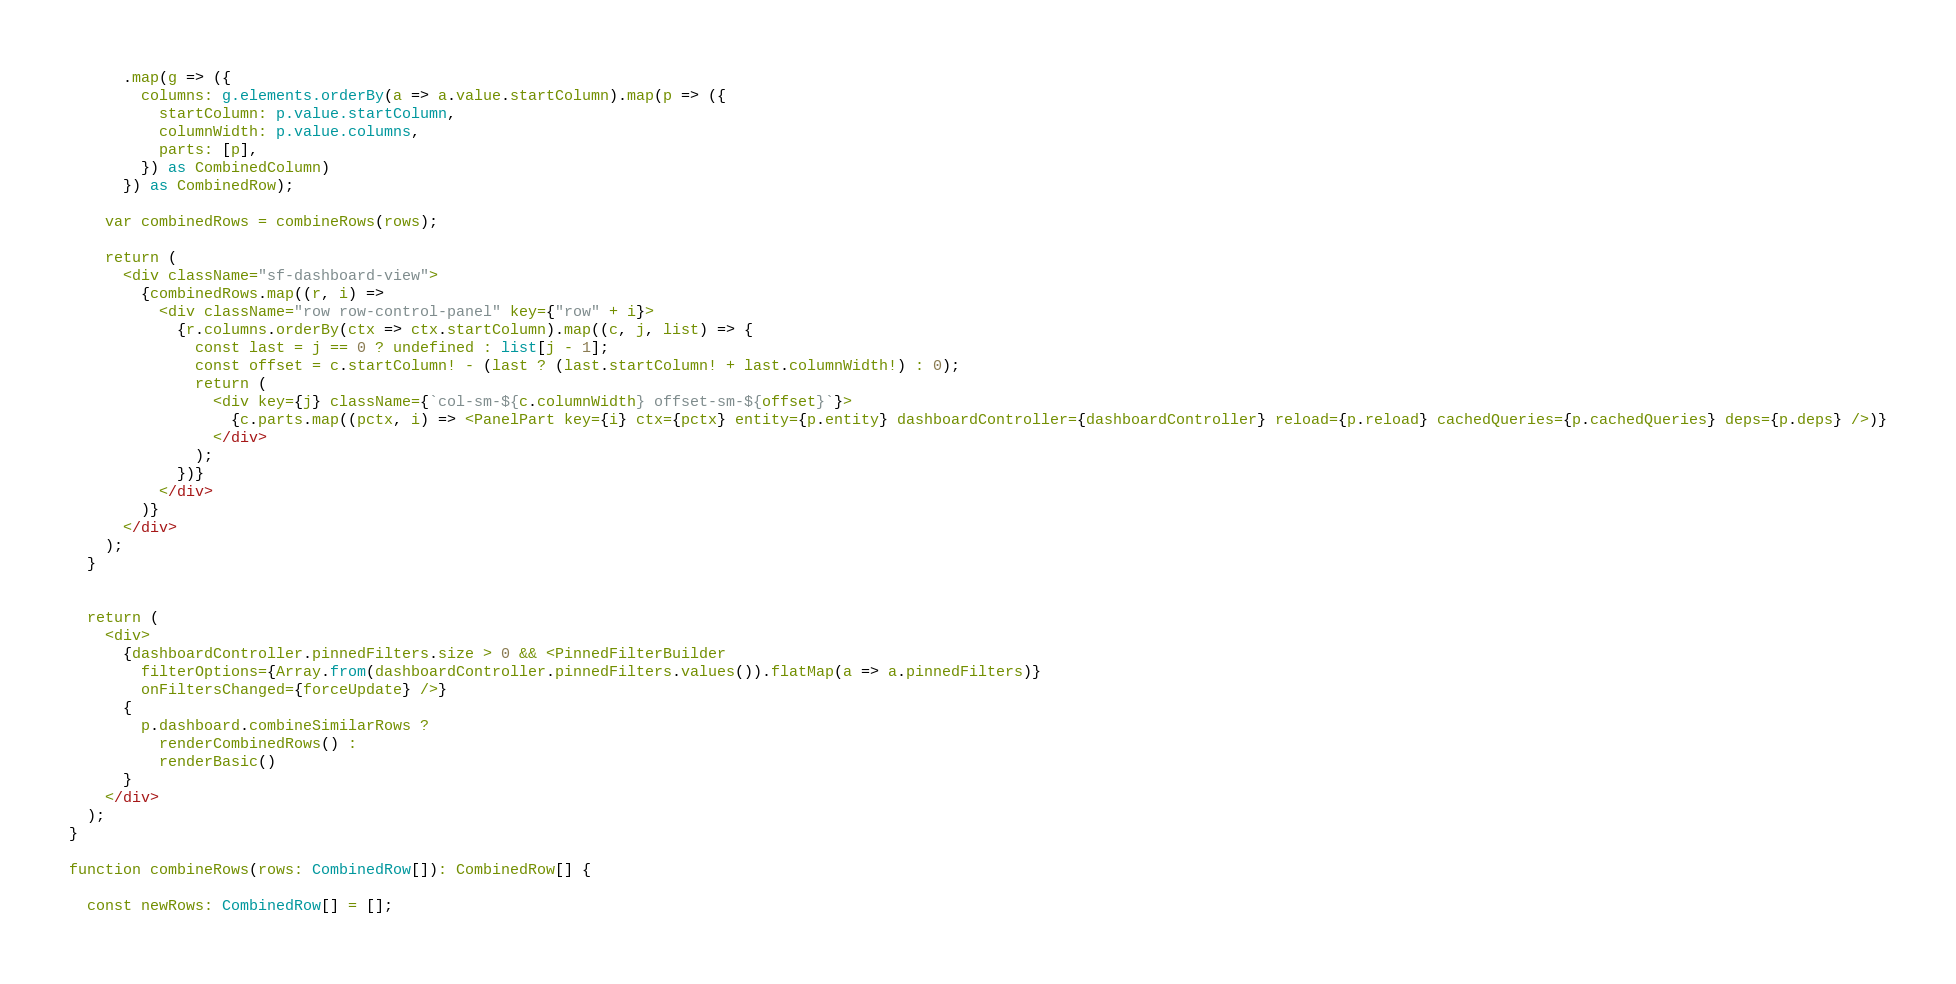<code> <loc_0><loc_0><loc_500><loc_500><_TypeScript_>      .map(g => ({
        columns: g.elements.orderBy(a => a.value.startColumn).map(p => ({
          startColumn: p.value.startColumn,
          columnWidth: p.value.columns,
          parts: [p],
        }) as CombinedColumn)
      }) as CombinedRow);

    var combinedRows = combineRows(rows);

    return (
      <div className="sf-dashboard-view">
        {combinedRows.map((r, i) =>
          <div className="row row-control-panel" key={"row" + i}>
            {r.columns.orderBy(ctx => ctx.startColumn).map((c, j, list) => {
              const last = j == 0 ? undefined : list[j - 1];
              const offset = c.startColumn! - (last ? (last.startColumn! + last.columnWidth!) : 0);
              return (
                <div key={j} className={`col-sm-${c.columnWidth} offset-sm-${offset}`}>
                  {c.parts.map((pctx, i) => <PanelPart key={i} ctx={pctx} entity={p.entity} dashboardController={dashboardController} reload={p.reload} cachedQueries={p.cachedQueries} deps={p.deps} />)}
                </div>
              );
            })}
          </div>
        )}
      </div>
    );
  }


  return (
    <div>
      {dashboardController.pinnedFilters.size > 0 && <PinnedFilterBuilder
        filterOptions={Array.from(dashboardController.pinnedFilters.values()).flatMap(a => a.pinnedFilters)}
        onFiltersChanged={forceUpdate} />}
      {
        p.dashboard.combineSimilarRows ?
          renderCombinedRows() :
          renderBasic()
      }
    </div>
  );
}

function combineRows(rows: CombinedRow[]): CombinedRow[] {

  const newRows: CombinedRow[] = [];
</code> 